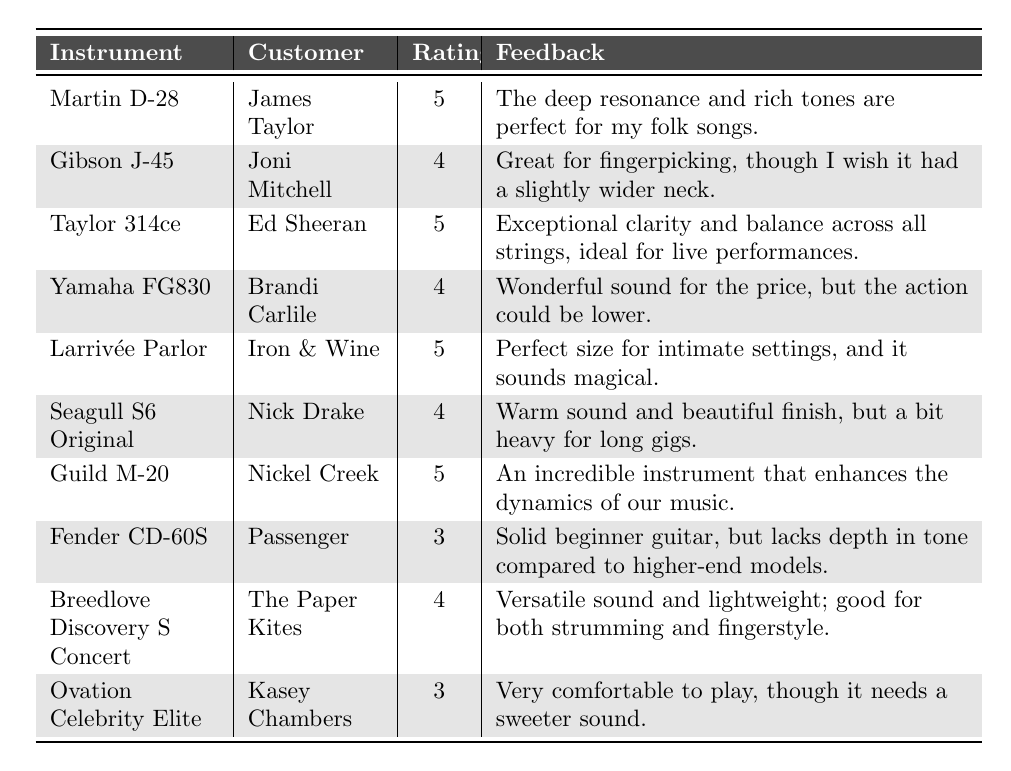What is the highest rating received for an instrument in the table? The highest rating in the table is 5. I can identify this by looking at the "Rating" column and finding the maximum value.
Answer: 5 Which instrument was rated the lowest, and who was the customer? The instrument with the lowest rating is the Fender CD-60S and the customer is Passenger. This is found by scanning the "Rating" column for the minimum value and checking the corresponding "Instrument" and "Customer."
Answer: Fender CD-60S, Passenger How many instruments received a rating of 4 or higher? There are 6 instruments that received ratings of 4 or higher. To find this, count the entries with a rating of 4 or 5 in the "Rating" column.
Answer: 6 What is the average rating of all the instruments listed? The total ratings are (5 + 4 + 5 + 4 + 5 + 4 + 5 + 3 + 4 + 3) = 46 and there are 10 instruments, so the average rating is 46/10 = 4.6.
Answer: 4.6 Did any customers provide feedback about the action of their instrument? Yes, both Brandi Carlile and Joni Mitchell gave feedback related to the action of their instruments, mentioning it could be improved. This is determined by looking for keywords like "action" in the "Feedback" column.
Answer: Yes Which instrument has feedback stating it is great for fingerpicking? The Gibson J-45 has feedback mentioning it is great for fingerpicking, referred to in the "Feedback" column.
Answer: Gibson J-45 What proportion of the instruments are rated above 3? A total of 8 instruments are rated above 3 out of 10, leading to a proportion of 8/10 = 0.8, or 80%. You deduce this by counting the ratings above 3 in the "Rating" column.
Answer: 80% Are there any instruments that have feedback considering their size adequate for intimate settings? Yes, the Larrivée Parlor is mentioned to be the perfect size for intimate settings. This is found by reviewing the feedback provided in the "Feedback" column.
Answer: Yes How many customers rated their instruments with a rating of 3? There are 2 customers who rated their instruments with a rating of 3, identified by scanning the "Rating" column for the number of times 3 appears.
Answer: 2 Is the feedback for the Taylor 314ce positive or negative? The feedback for the Taylor 314ce is positive, highlighting exceptional clarity and balance. This is concluded from reading the feedback associated with this instrument.
Answer: Positive 